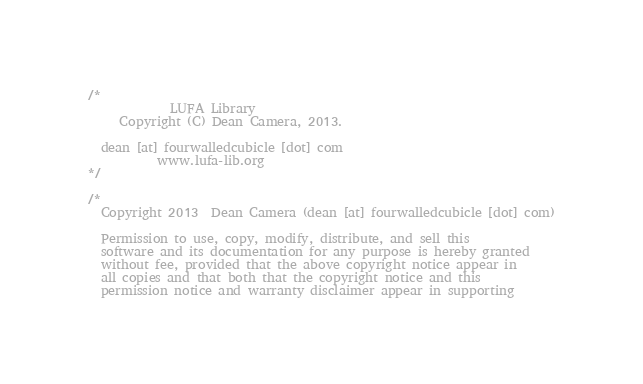Convert code to text. <code><loc_0><loc_0><loc_500><loc_500><_C_>/*
             LUFA Library
     Copyright (C) Dean Camera, 2013.

  dean [at] fourwalledcubicle [dot] com
           www.lufa-lib.org
*/

/*
  Copyright 2013  Dean Camera (dean [at] fourwalledcubicle [dot] com)

  Permission to use, copy, modify, distribute, and sell this
  software and its documentation for any purpose is hereby granted
  without fee, provided that the above copyright notice appear in
  all copies and that both that the copyright notice and this
  permission notice and warranty disclaimer appear in supporting</code> 